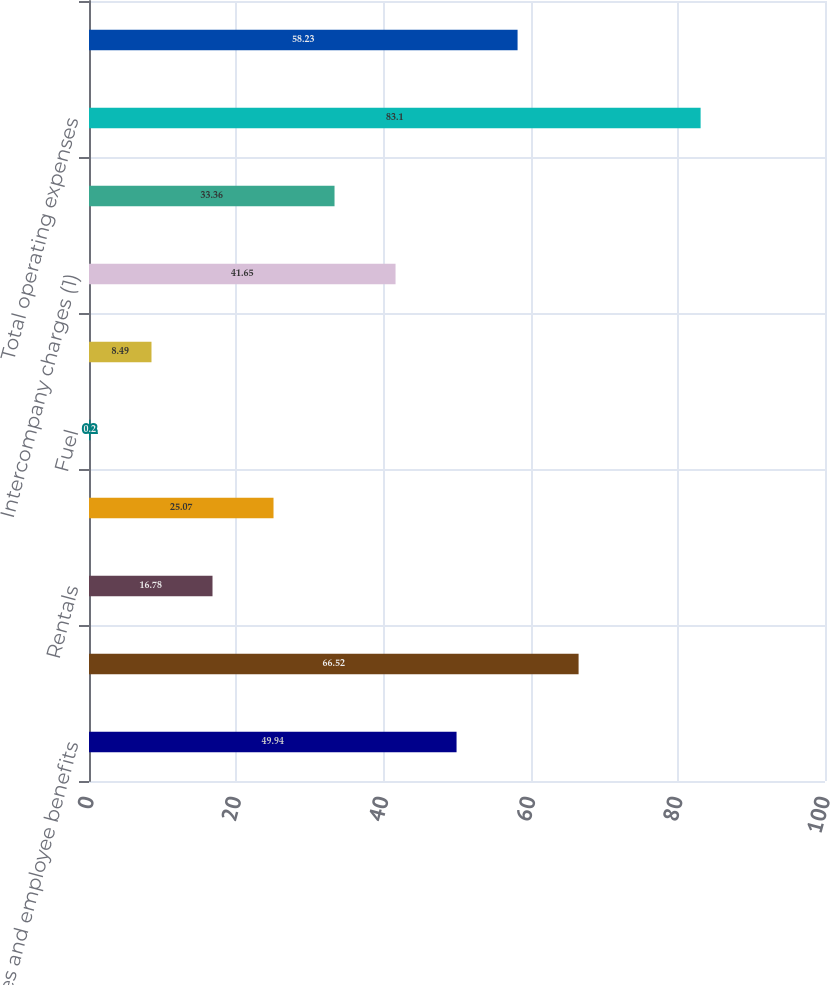<chart> <loc_0><loc_0><loc_500><loc_500><bar_chart><fcel>Salaries and employee benefits<fcel>Purchased transportation<fcel>Rentals<fcel>Depreciation and amortization<fcel>Fuel<fcel>Maintenance and repairs<fcel>Intercompany charges (1)<fcel>Other<fcel>Total operating expenses<fcel>Operating margin (1)<nl><fcel>49.94<fcel>66.52<fcel>16.78<fcel>25.07<fcel>0.2<fcel>8.49<fcel>41.65<fcel>33.36<fcel>83.1<fcel>58.23<nl></chart> 